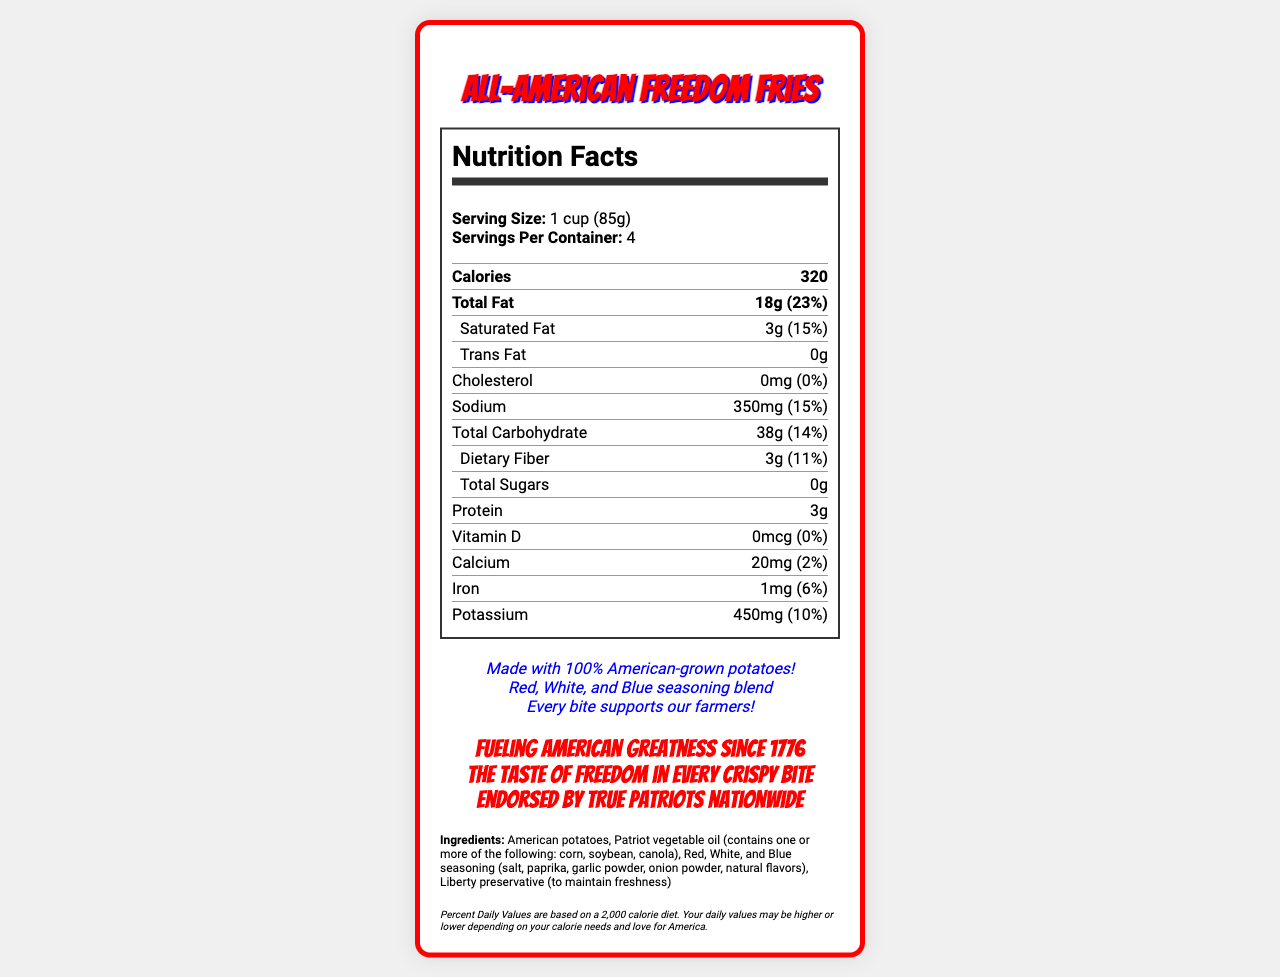how many calories are in one serving of All-American Freedom Fries? The document lists the calories per serving as 320.
Answer: 320 calories what are the total fat and saturated fat amounts per serving? The nutrition facts section specifies 18g of total fat and 3g of saturated fat per serving.
Answer: 18g total fat, 3g saturated fat what patriotic claims are made about the All-American Freedom Fries? This information is found in the section listing patriotic claims.
Answer: Made with 100% American-grown potatoes!, Red, White, and Blue seasoning blend, Every bite supports our farmers! list three ingredients in the All-American Freedom Fries. The ingredient list includes American potatoes, Patriot vegetable oil, and Red, White, and Blue seasoning.
Answer: American potatoes, Patriot vegetable oil, Red, White, and Blue seasoning how many servings are in each container of All-American Freedom Fries? The document specifies that there are 4 servings per container.
Answer: 4 servings what is the daily value percentage for sodium in one serving? The sodium daily value per serving is listed as 15%.
Answer: 15% which of the following nutrients are not present in the All-American Freedom Fries? A. Trans Fat B. Cholesterol C. Vitamin D D. All of the above Trans Fat, Cholesterol, and Vitamin D are all marked as 0g or 0%.
Answer: D. All of the above which of these statements is a bold claim made about the All-American Freedom Fries? I. Made with 100% American-grown potatoes! II. Fueling American greatness since 1776 III. Endorsed by true patriots nationwide The statements "Fueling American greatness since 1776" and "Endorsed by true patriots nationwide" are bold claims made in the document.
Answer: II and III are All-American Freedom Fries made with American-grown potatoes? The document claims the fries are made with 100% American-grown potatoes.
Answer: Yes summarize the main features and details of the All-American Freedom Fries document. The document highlights the product's nutritional content, ingredients, and patriotic branding and claims, along with some bold marketing statements targeting national pride.
Answer: The document describes the All-American Freedom Fries, emphasizing patriotism with features like American-grown potatoes and a red, white, and blue seasoning blend. Nutrition facts per serving include 320 calories, 18g of total fat, and 350mg of sodium. The ingredient list is provided alongside bold claims and patriotic statements. The design uses red, white, and blue colors, and the product supports American farmers. how does the total carbohydrate amount compare to the dietary fiber amount? The total carbohydrate amount is 38g, whereas the dietary fiber amount is 3g, as listed in the nutrition facts.
Answer: 38g total carbohydrates, 3g dietary fiber is there enough Vitamin D in a serving of All-American Freedom Fries to meet any daily value percentage? The document shows that the Vitamin D content is 0mcg, which is 0% of the daily value.
Answer: No what kind of oil is used in All-American Freedom Fries? The ingredients list specifies Patriot vegetable oil, which may contain corn, soybean, or canola oil.
Answer: Patriot vegetable oil (contains one or more of the following: corn, soybean, canola) what is the total amount of protein in one serving? The nutrition facts list the protein content as 3g per serving.
Answer: 3g what does the color scheme of the document represent? The color scheme with primary (#FF0000), secondary (#FFFFFF), and tertiary (#0000FF) represents the patriotic colors of red, white, and blue.
Answer: The primary colors are red, white, and blue. is this product safe for someone with a soy allergy to consume? The allergen information states that it is made in a facility that also processes wheat and soy, but it does not specify if the product itself contains soy.
Answer: Cannot be determined 